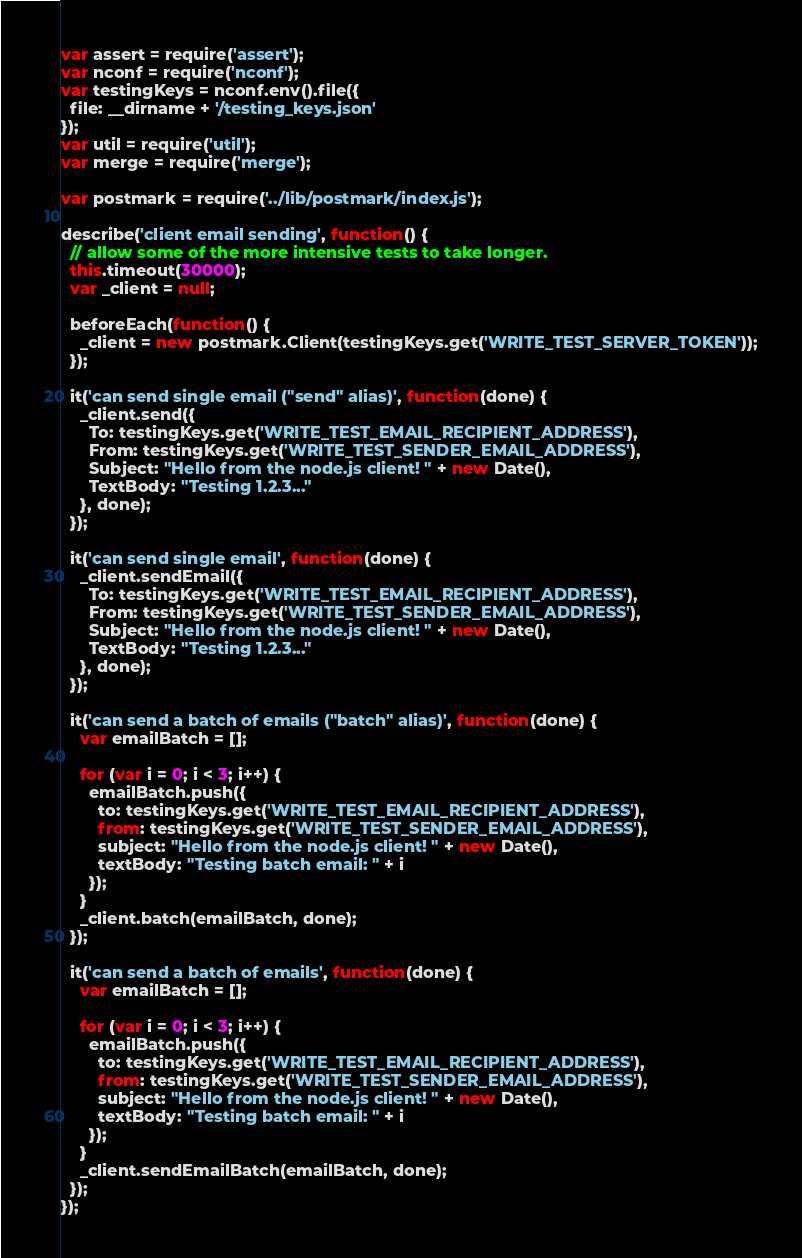Convert code to text. <code><loc_0><loc_0><loc_500><loc_500><_JavaScript_>var assert = require('assert');
var nconf = require('nconf');
var testingKeys = nconf.env().file({
  file: __dirname + '/testing_keys.json'
});
var util = require('util');
var merge = require('merge');

var postmark = require('../lib/postmark/index.js');

describe('client email sending', function() {
  // allow some of the more intensive tests to take longer.
  this.timeout(30000);
  var _client = null;

  beforeEach(function() {
    _client = new postmark.Client(testingKeys.get('WRITE_TEST_SERVER_TOKEN'));
  });

  it('can send single email ("send" alias)', function(done) {
    _client.send({
      To: testingKeys.get('WRITE_TEST_EMAIL_RECIPIENT_ADDRESS'),
      From: testingKeys.get('WRITE_TEST_SENDER_EMAIL_ADDRESS'),
      Subject: "Hello from the node.js client! " + new Date(),
      TextBody: "Testing 1.2.3..."
    }, done);
  });

  it('can send single email', function(done) {
    _client.sendEmail({
      To: testingKeys.get('WRITE_TEST_EMAIL_RECIPIENT_ADDRESS'),
      From: testingKeys.get('WRITE_TEST_SENDER_EMAIL_ADDRESS'),
      Subject: "Hello from the node.js client! " + new Date(),
      TextBody: "Testing 1.2.3..."
    }, done);
  });

  it('can send a batch of emails ("batch" alias)', function(done) {
    var emailBatch = [];

    for (var i = 0; i < 3; i++) {
      emailBatch.push({
        to: testingKeys.get('WRITE_TEST_EMAIL_RECIPIENT_ADDRESS'),
        from: testingKeys.get('WRITE_TEST_SENDER_EMAIL_ADDRESS'),
        subject: "Hello from the node.js client! " + new Date(),
        textBody: "Testing batch email: " + i
      });
    }
    _client.batch(emailBatch, done);
  });

  it('can send a batch of emails', function(done) {
    var emailBatch = [];

    for (var i = 0; i < 3; i++) {
      emailBatch.push({
        to: testingKeys.get('WRITE_TEST_EMAIL_RECIPIENT_ADDRESS'),
        from: testingKeys.get('WRITE_TEST_SENDER_EMAIL_ADDRESS'),
        subject: "Hello from the node.js client! " + new Date(),
        textBody: "Testing batch email: " + i
      });
    }
    _client.sendEmailBatch(emailBatch, done);
  });
});</code> 